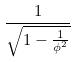<formula> <loc_0><loc_0><loc_500><loc_500>\frac { 1 } { \sqrt { 1 - \frac { 1 } { \phi ^ { 2 } } } }</formula> 